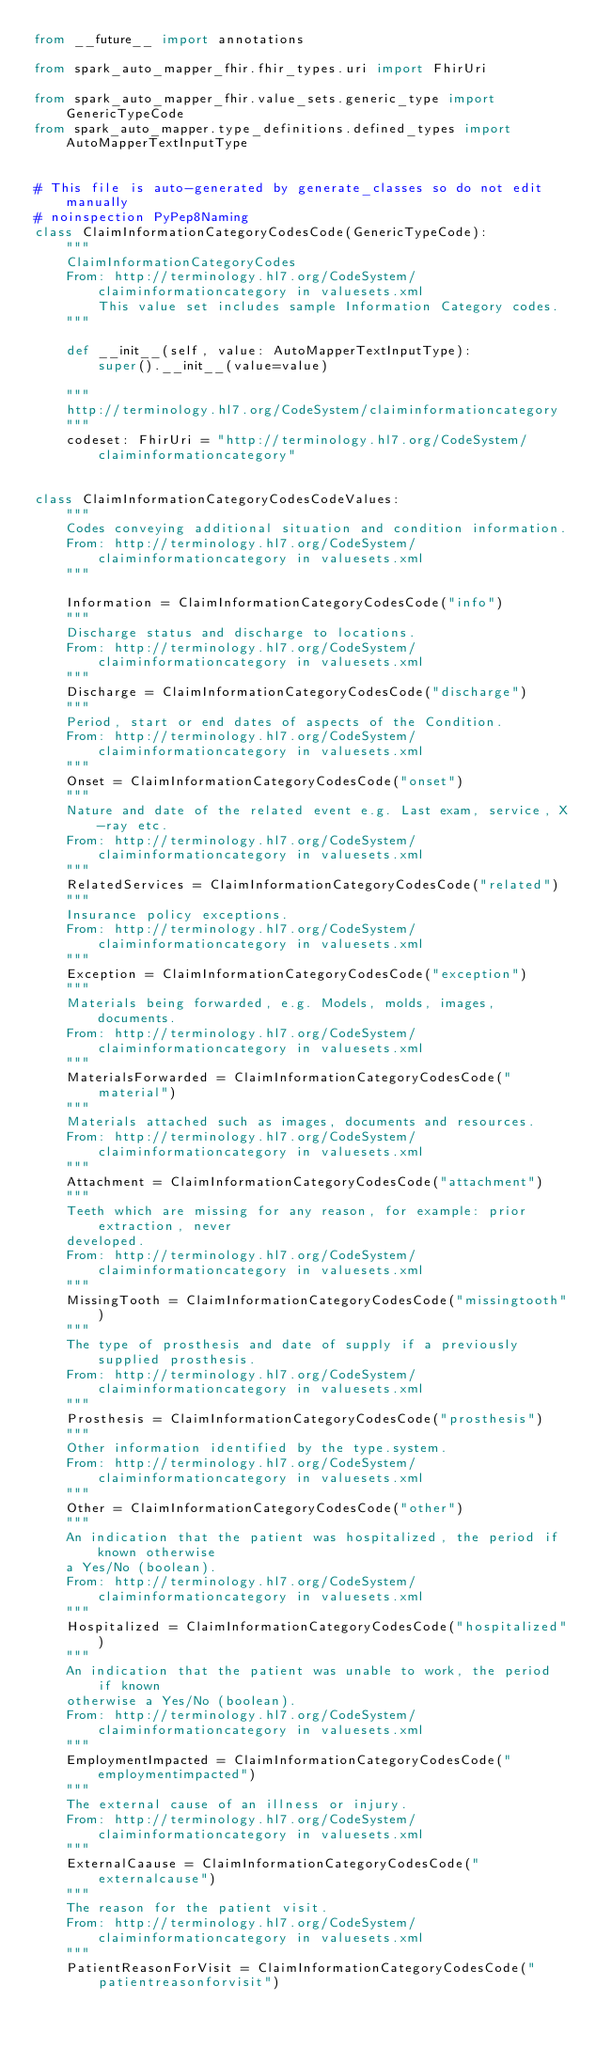Convert code to text. <code><loc_0><loc_0><loc_500><loc_500><_Python_>from __future__ import annotations

from spark_auto_mapper_fhir.fhir_types.uri import FhirUri

from spark_auto_mapper_fhir.value_sets.generic_type import GenericTypeCode
from spark_auto_mapper.type_definitions.defined_types import AutoMapperTextInputType


# This file is auto-generated by generate_classes so do not edit manually
# noinspection PyPep8Naming
class ClaimInformationCategoryCodesCode(GenericTypeCode):
    """
    ClaimInformationCategoryCodes
    From: http://terminology.hl7.org/CodeSystem/claiminformationcategory in valuesets.xml
        This value set includes sample Information Category codes.
    """

    def __init__(self, value: AutoMapperTextInputType):
        super().__init__(value=value)

    """
    http://terminology.hl7.org/CodeSystem/claiminformationcategory
    """
    codeset: FhirUri = "http://terminology.hl7.org/CodeSystem/claiminformationcategory"


class ClaimInformationCategoryCodesCodeValues:
    """
    Codes conveying additional situation and condition information.
    From: http://terminology.hl7.org/CodeSystem/claiminformationcategory in valuesets.xml
    """

    Information = ClaimInformationCategoryCodesCode("info")
    """
    Discharge status and discharge to locations.
    From: http://terminology.hl7.org/CodeSystem/claiminformationcategory in valuesets.xml
    """
    Discharge = ClaimInformationCategoryCodesCode("discharge")
    """
    Period, start or end dates of aspects of the Condition.
    From: http://terminology.hl7.org/CodeSystem/claiminformationcategory in valuesets.xml
    """
    Onset = ClaimInformationCategoryCodesCode("onset")
    """
    Nature and date of the related event e.g. Last exam, service, X-ray etc.
    From: http://terminology.hl7.org/CodeSystem/claiminformationcategory in valuesets.xml
    """
    RelatedServices = ClaimInformationCategoryCodesCode("related")
    """
    Insurance policy exceptions.
    From: http://terminology.hl7.org/CodeSystem/claiminformationcategory in valuesets.xml
    """
    Exception = ClaimInformationCategoryCodesCode("exception")
    """
    Materials being forwarded, e.g. Models, molds, images, documents.
    From: http://terminology.hl7.org/CodeSystem/claiminformationcategory in valuesets.xml
    """
    MaterialsForwarded = ClaimInformationCategoryCodesCode("material")
    """
    Materials attached such as images, documents and resources.
    From: http://terminology.hl7.org/CodeSystem/claiminformationcategory in valuesets.xml
    """
    Attachment = ClaimInformationCategoryCodesCode("attachment")
    """
    Teeth which are missing for any reason, for example: prior extraction, never
    developed.
    From: http://terminology.hl7.org/CodeSystem/claiminformationcategory in valuesets.xml
    """
    MissingTooth = ClaimInformationCategoryCodesCode("missingtooth")
    """
    The type of prosthesis and date of supply if a previously supplied prosthesis.
    From: http://terminology.hl7.org/CodeSystem/claiminformationcategory in valuesets.xml
    """
    Prosthesis = ClaimInformationCategoryCodesCode("prosthesis")
    """
    Other information identified by the type.system.
    From: http://terminology.hl7.org/CodeSystem/claiminformationcategory in valuesets.xml
    """
    Other = ClaimInformationCategoryCodesCode("other")
    """
    An indication that the patient was hospitalized, the period if known otherwise
    a Yes/No (boolean).
    From: http://terminology.hl7.org/CodeSystem/claiminformationcategory in valuesets.xml
    """
    Hospitalized = ClaimInformationCategoryCodesCode("hospitalized")
    """
    An indication that the patient was unable to work, the period if known
    otherwise a Yes/No (boolean).
    From: http://terminology.hl7.org/CodeSystem/claiminformationcategory in valuesets.xml
    """
    EmploymentImpacted = ClaimInformationCategoryCodesCode("employmentimpacted")
    """
    The external cause of an illness or injury.
    From: http://terminology.hl7.org/CodeSystem/claiminformationcategory in valuesets.xml
    """
    ExternalCaause = ClaimInformationCategoryCodesCode("externalcause")
    """
    The reason for the patient visit.
    From: http://terminology.hl7.org/CodeSystem/claiminformationcategory in valuesets.xml
    """
    PatientReasonForVisit = ClaimInformationCategoryCodesCode("patientreasonforvisit")
</code> 